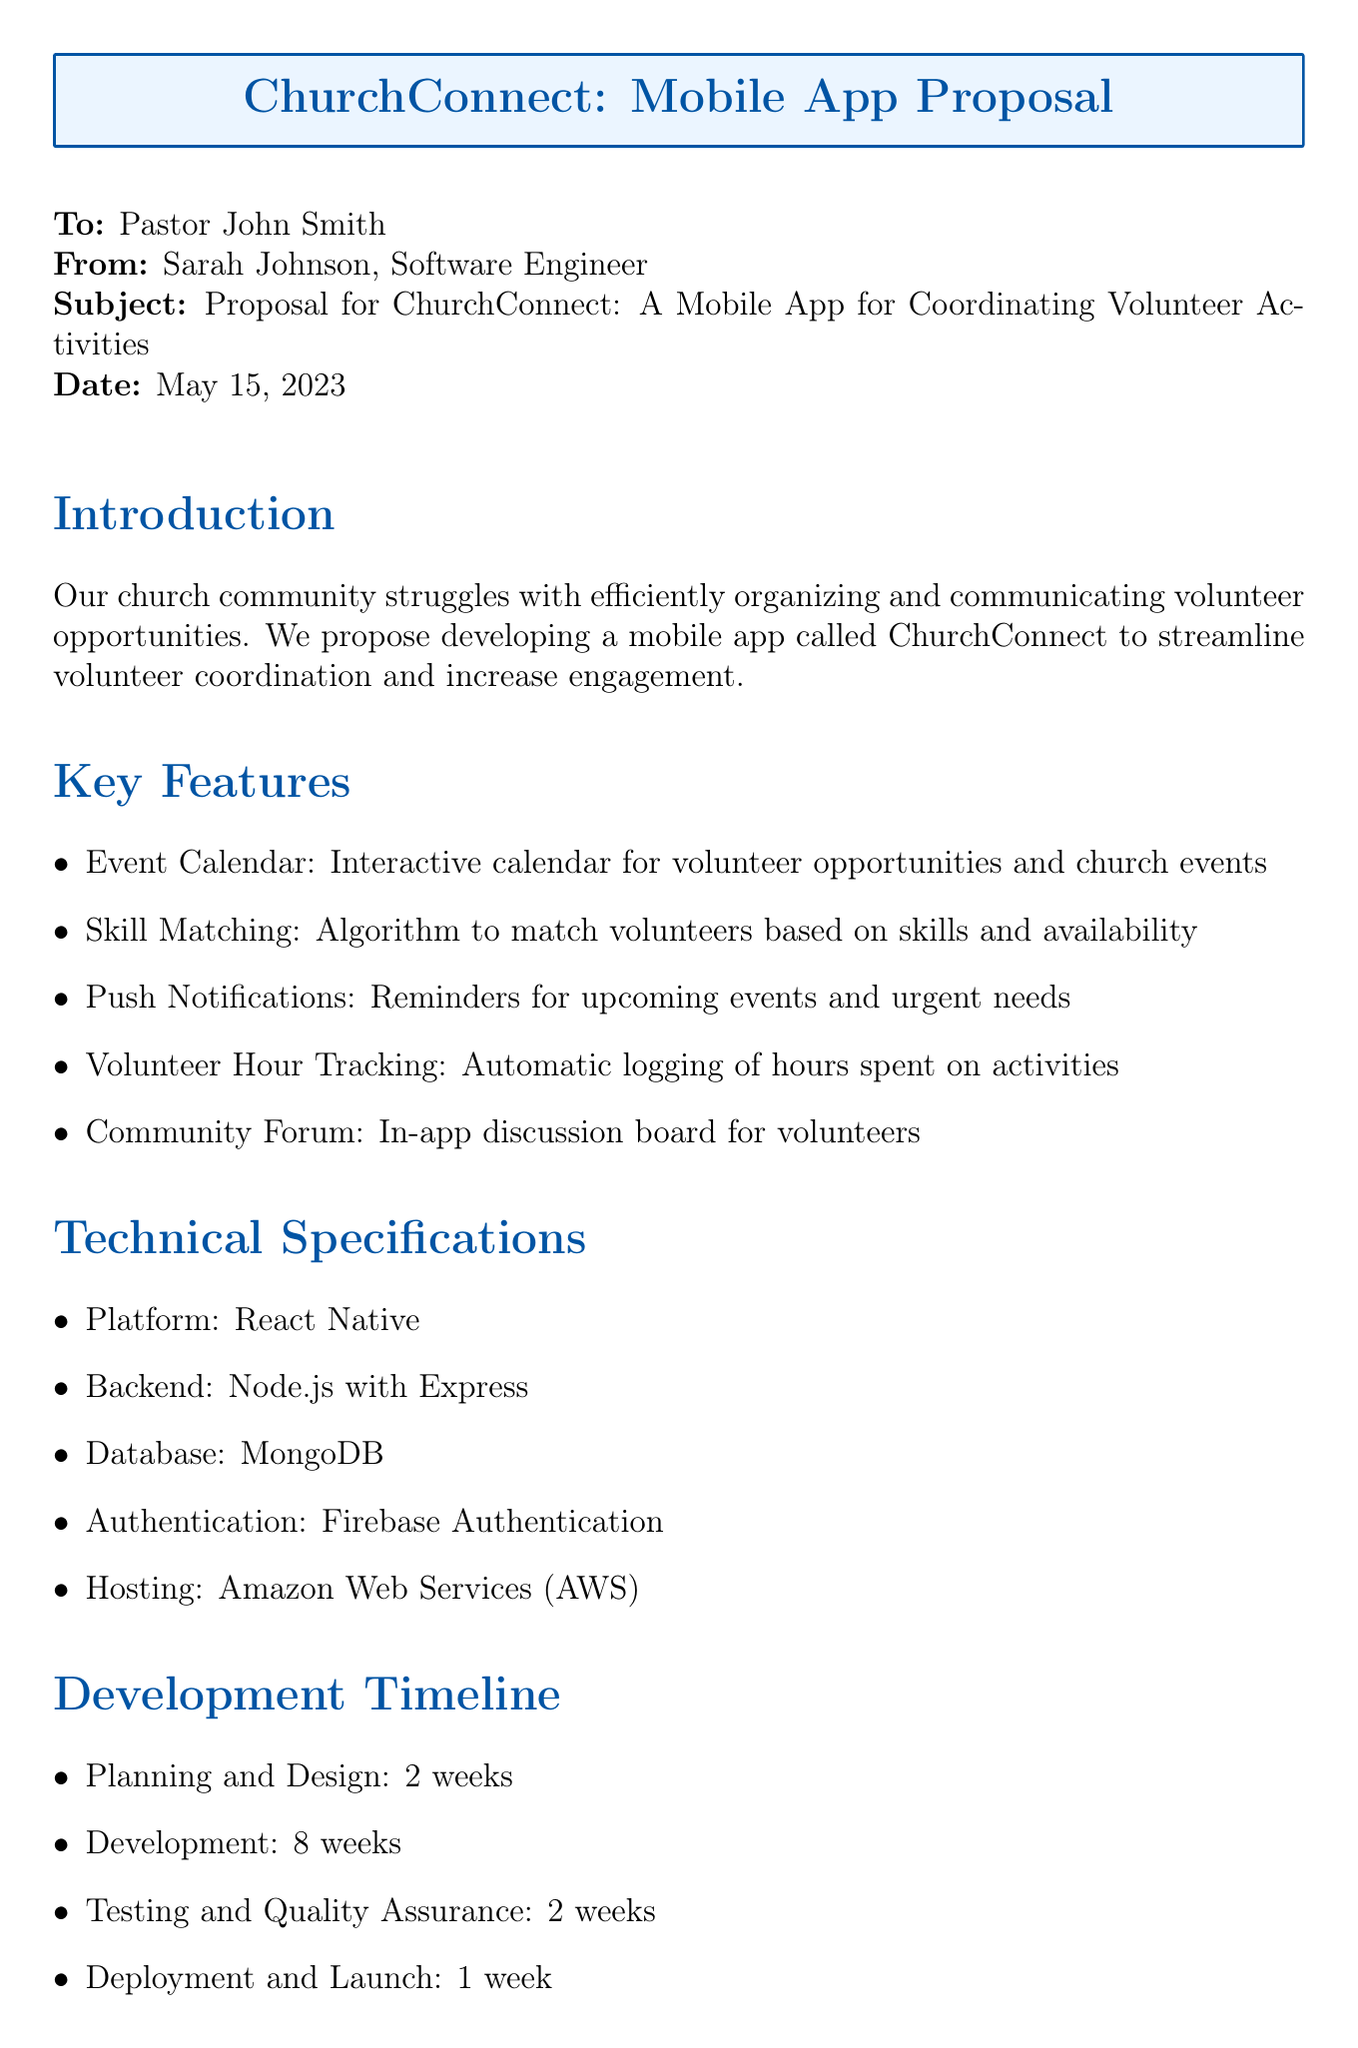what is the title of the proposal? The title of the proposal is found in the subject line of the memo, which contains the name of the app and its purpose.
Answer: Proposal for ChurchConnect: A Mobile App for Coordinating Volunteer Activities who is the sender of the memo? The sender's name is provided in the "From" section of the memo.
Answer: Sarah Johnson, Software Engineer how long is the development phase of the app? The total development time is summarized in the development timeline section, specifically indicating the duration allocated for development.
Answer: 8 weeks what are the ongoing maintenance costs per month? The ongoing maintenance costs are specified in the budget estimation section of the memo.
Answer: $500 per month what is the proposed solution to the problem identified? The proposed solution can be found in the introduction, where the app name is mentioned along with its purpose.
Answer: Develop a mobile app called ChurchConnect to streamline volunteer coordination and increase engagement how does the app plan to improve communication between church leadership and volunteers? This benefit is mentioned in the benefits section, which summarizes the positive impacts of the app.
Answer: Improved communication between church leadership and volunteers what is the platform used for the app development? The platform is specified in the technical specifications section of the memo.
Answer: React Native who is the recipient of the memo? The recipient's name is found in the "To" section of the memo, indicating the person to whom it is addressed.
Answer: Pastor John Smith what is the first step outlined in the implementation plan? The implementation plan details the steps to take, and the first step is highlighted in that section.
Answer: Form a project team consisting of church staff and tech-savvy volunteers 